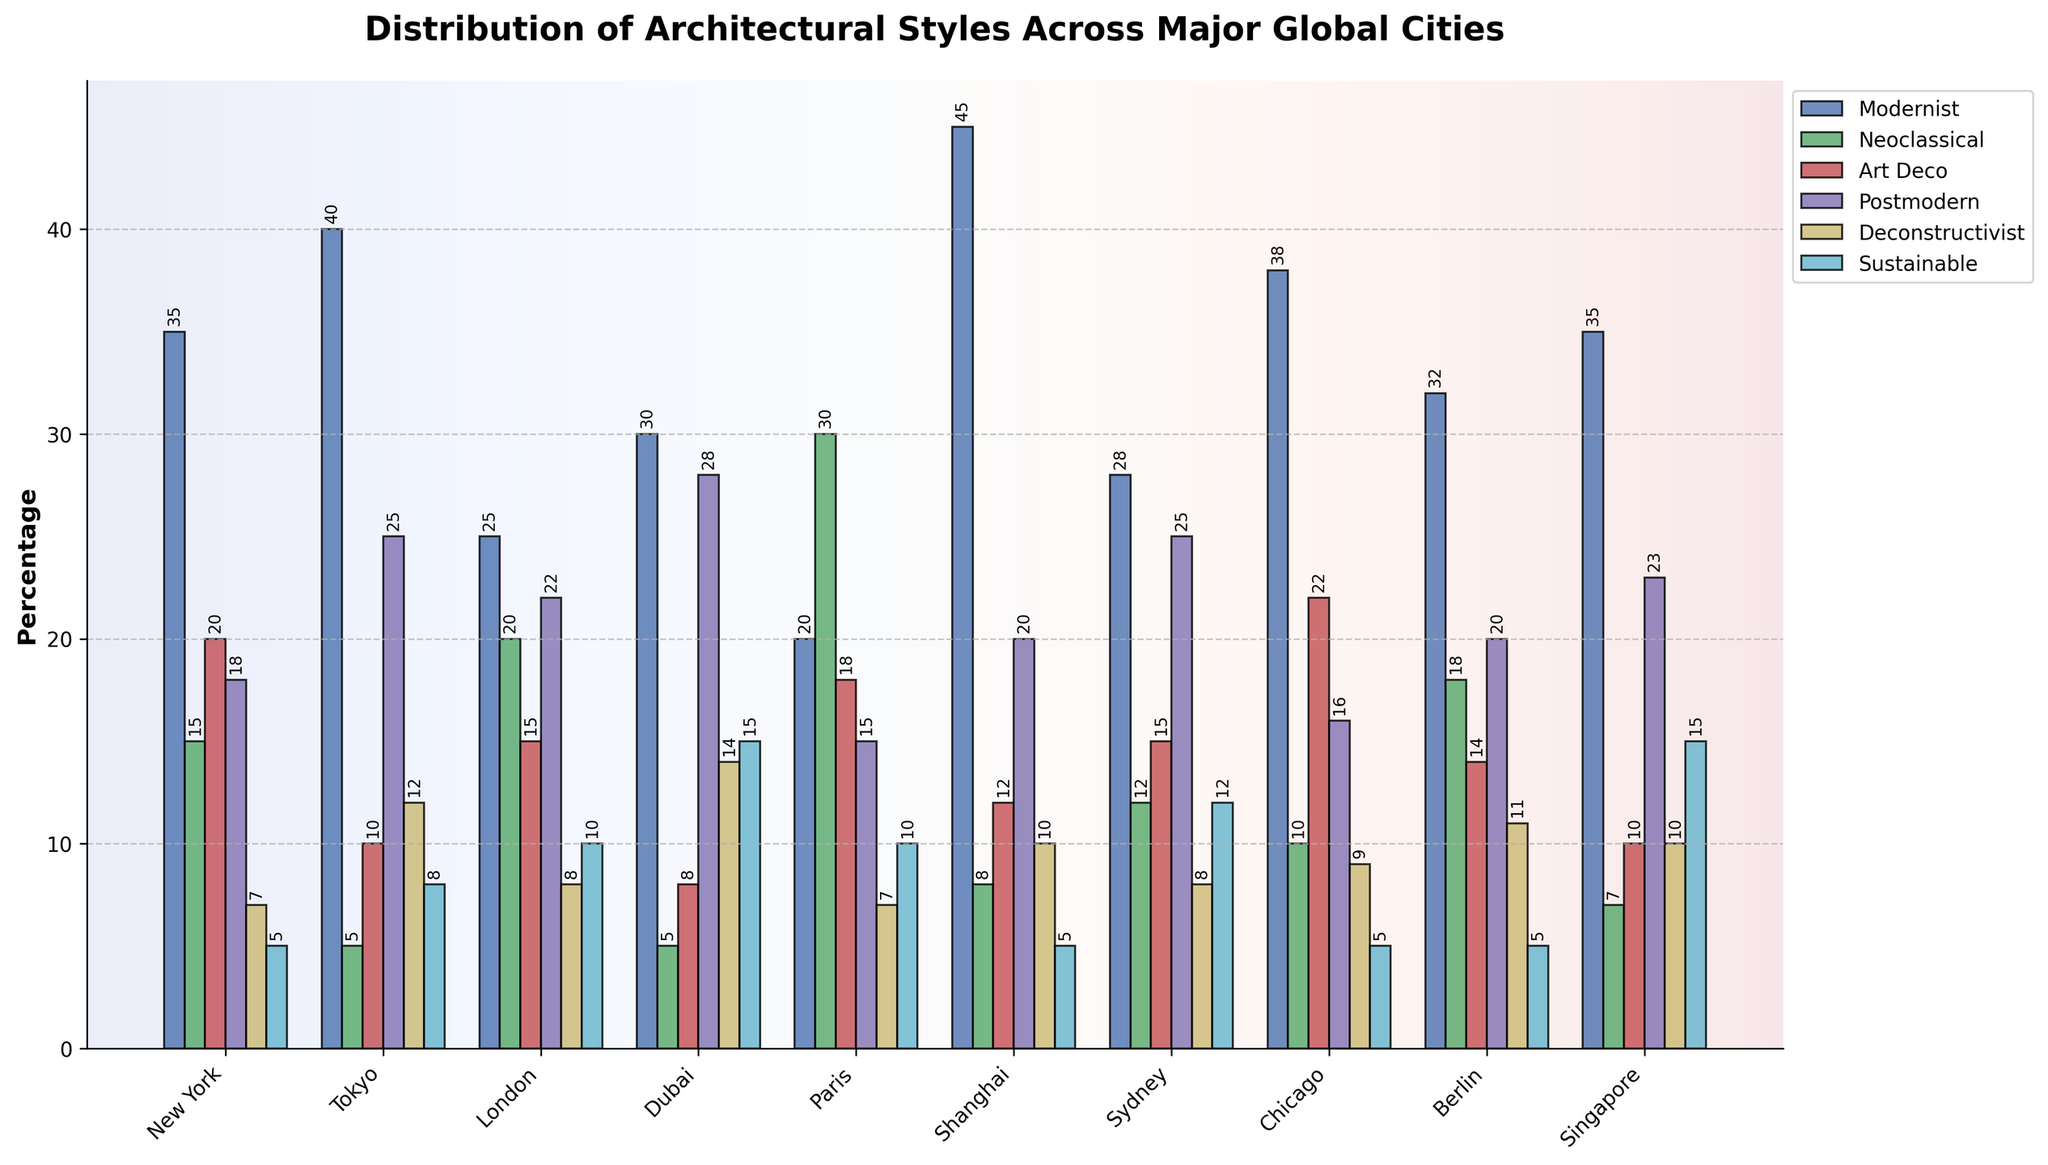Which city has the highest percentage of Modernist architecture? The tallest bar in the Modernist category can be observed in the city of Shanghai, which has the highest percentage.
Answer: Shanghai What is the difference in percentage between the cities with the highest and lowest Sustainable architecture? The city with the highest percentage of Sustainable architecture is Dubai at 15%, and the lowest are New York, Shanghai, Berlin, and Chicago, each at 5%. The difference is 15% - 5% = 10%.
Answer: 10% Which city has more Postmodern architecture, Tokyo or Sydney? In the Postmodern category, Tokyo has a bar height representing 25%, while Sydney has a bar height representing 25% as well. Therefore, both cities have equal percentages of Postmodern architecture.
Answer: Both cities have equal percentages Out of New York, Paris, and Berlin, which city has the least percentage of Neoclassical architecture? The bar heights in the Neoclassical category for New York, Paris, and Berlin are 15%, 30%, and 18%, respectively. New York has the least with 15%.
Answer: New York What is the combined percentage of Art Deco and Deconstructivist architecture in Chicago? The bar heights for Art Deco and Deconstructivist in Chicago are 22% and 9%, respectively. Adding them gives 22% + 9% = 31%.
Answer: 31% How does the percentage of Neoclassical architecture in London compare to that in Paris? The bar height for Neoclassical in London is 20%, whereas in Paris, it's 30%. Paris has a higher percentage by 10%.
Answer: Paris has 10% more Which architectural style has the most similar percentage across all cities? By visual comparison of the heights of the bars for each architectural style, the Deconstructivist style shows the most consistent heights with slight variations across the cities.
Answer: Deconstructivist If you combine the percentage of Modernist and Sustainable architecture in Singapore, does it surpass the total percentage of Sustainable architecture in Dubai? Singapore's Modernist is 35% and Sustainable is 15%, totaling 50%. Dubai's Sustainable is 15%. 50% > 15%, hence it surpasses.
Answer: Yes, it surpasses Which city has the greatest variety in the distribution of architectural styles? By observing the difference in bar heights per style in each city, New York shows a significant variety, with noticeable differences across Modernist, Neoclassical, Art Deco, Postmodern, Deconstructivist, and Sustainable categories.
Answer: New York 